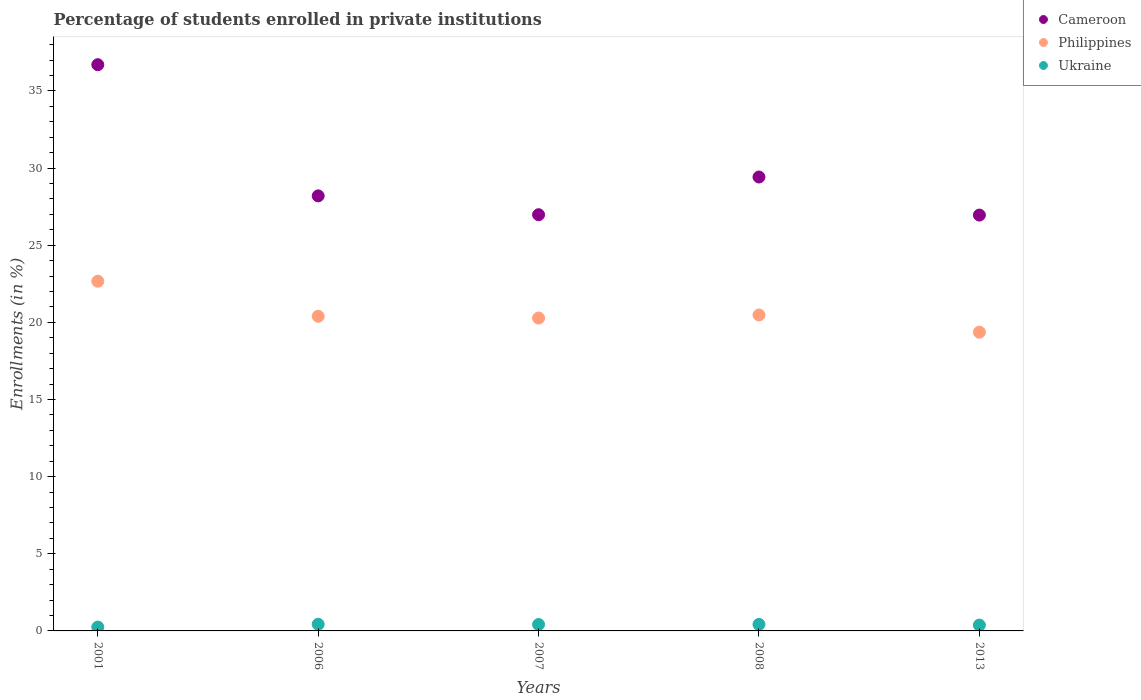Is the number of dotlines equal to the number of legend labels?
Offer a very short reply. Yes. What is the percentage of trained teachers in Ukraine in 2006?
Your response must be concise. 0.43. Across all years, what is the maximum percentage of trained teachers in Philippines?
Your response must be concise. 22.67. Across all years, what is the minimum percentage of trained teachers in Philippines?
Provide a succinct answer. 19.36. In which year was the percentage of trained teachers in Cameroon minimum?
Provide a succinct answer. 2013. What is the total percentage of trained teachers in Philippines in the graph?
Your response must be concise. 103.17. What is the difference between the percentage of trained teachers in Philippines in 2001 and that in 2013?
Offer a very short reply. 3.3. What is the difference between the percentage of trained teachers in Ukraine in 2007 and the percentage of trained teachers in Cameroon in 2008?
Provide a succinct answer. -29. What is the average percentage of trained teachers in Cameroon per year?
Keep it short and to the point. 29.65. In the year 2006, what is the difference between the percentage of trained teachers in Ukraine and percentage of trained teachers in Cameroon?
Keep it short and to the point. -27.76. What is the ratio of the percentage of trained teachers in Philippines in 2001 to that in 2006?
Offer a terse response. 1.11. Is the percentage of trained teachers in Cameroon in 2001 less than that in 2013?
Offer a terse response. No. What is the difference between the highest and the second highest percentage of trained teachers in Philippines?
Make the answer very short. 2.19. What is the difference between the highest and the lowest percentage of trained teachers in Cameroon?
Offer a very short reply. 9.75. In how many years, is the percentage of trained teachers in Philippines greater than the average percentage of trained teachers in Philippines taken over all years?
Offer a terse response. 1. Is it the case that in every year, the sum of the percentage of trained teachers in Philippines and percentage of trained teachers in Ukraine  is greater than the percentage of trained teachers in Cameroon?
Your answer should be compact. No. Does the percentage of trained teachers in Cameroon monotonically increase over the years?
Your answer should be very brief. No. How many dotlines are there?
Your answer should be very brief. 3. Does the graph contain any zero values?
Give a very brief answer. No. What is the title of the graph?
Offer a very short reply. Percentage of students enrolled in private institutions. Does "Latvia" appear as one of the legend labels in the graph?
Ensure brevity in your answer.  No. What is the label or title of the X-axis?
Provide a short and direct response. Years. What is the label or title of the Y-axis?
Give a very brief answer. Enrollments (in %). What is the Enrollments (in %) in Cameroon in 2001?
Offer a very short reply. 36.7. What is the Enrollments (in %) in Philippines in 2001?
Ensure brevity in your answer.  22.67. What is the Enrollments (in %) in Ukraine in 2001?
Ensure brevity in your answer.  0.25. What is the Enrollments (in %) in Cameroon in 2006?
Make the answer very short. 28.2. What is the Enrollments (in %) of Philippines in 2006?
Provide a short and direct response. 20.39. What is the Enrollments (in %) in Ukraine in 2006?
Offer a terse response. 0.43. What is the Enrollments (in %) of Cameroon in 2007?
Provide a succinct answer. 26.98. What is the Enrollments (in %) in Philippines in 2007?
Provide a short and direct response. 20.28. What is the Enrollments (in %) of Ukraine in 2007?
Provide a succinct answer. 0.42. What is the Enrollments (in %) of Cameroon in 2008?
Make the answer very short. 29.42. What is the Enrollments (in %) of Philippines in 2008?
Your response must be concise. 20.48. What is the Enrollments (in %) of Ukraine in 2008?
Make the answer very short. 0.42. What is the Enrollments (in %) in Cameroon in 2013?
Provide a short and direct response. 26.95. What is the Enrollments (in %) of Philippines in 2013?
Your answer should be compact. 19.36. What is the Enrollments (in %) in Ukraine in 2013?
Provide a short and direct response. 0.38. Across all years, what is the maximum Enrollments (in %) in Cameroon?
Provide a succinct answer. 36.7. Across all years, what is the maximum Enrollments (in %) of Philippines?
Your answer should be very brief. 22.67. Across all years, what is the maximum Enrollments (in %) in Ukraine?
Your response must be concise. 0.43. Across all years, what is the minimum Enrollments (in %) of Cameroon?
Your response must be concise. 26.95. Across all years, what is the minimum Enrollments (in %) of Philippines?
Make the answer very short. 19.36. Across all years, what is the minimum Enrollments (in %) in Ukraine?
Keep it short and to the point. 0.25. What is the total Enrollments (in %) in Cameroon in the graph?
Keep it short and to the point. 148.24. What is the total Enrollments (in %) in Philippines in the graph?
Your answer should be very brief. 103.17. What is the total Enrollments (in %) of Ukraine in the graph?
Provide a short and direct response. 1.9. What is the difference between the Enrollments (in %) of Cameroon in 2001 and that in 2006?
Keep it short and to the point. 8.5. What is the difference between the Enrollments (in %) of Philippines in 2001 and that in 2006?
Your answer should be compact. 2.27. What is the difference between the Enrollments (in %) of Ukraine in 2001 and that in 2006?
Your answer should be very brief. -0.18. What is the difference between the Enrollments (in %) of Cameroon in 2001 and that in 2007?
Your answer should be very brief. 9.72. What is the difference between the Enrollments (in %) in Philippines in 2001 and that in 2007?
Provide a succinct answer. 2.39. What is the difference between the Enrollments (in %) of Ukraine in 2001 and that in 2007?
Your answer should be compact. -0.17. What is the difference between the Enrollments (in %) of Cameroon in 2001 and that in 2008?
Offer a very short reply. 7.28. What is the difference between the Enrollments (in %) of Philippines in 2001 and that in 2008?
Offer a very short reply. 2.19. What is the difference between the Enrollments (in %) in Ukraine in 2001 and that in 2008?
Provide a succinct answer. -0.17. What is the difference between the Enrollments (in %) of Cameroon in 2001 and that in 2013?
Provide a succinct answer. 9.75. What is the difference between the Enrollments (in %) of Philippines in 2001 and that in 2013?
Offer a very short reply. 3.3. What is the difference between the Enrollments (in %) in Ukraine in 2001 and that in 2013?
Your answer should be compact. -0.13. What is the difference between the Enrollments (in %) in Cameroon in 2006 and that in 2007?
Offer a very short reply. 1.22. What is the difference between the Enrollments (in %) of Philippines in 2006 and that in 2007?
Your answer should be compact. 0.12. What is the difference between the Enrollments (in %) of Ukraine in 2006 and that in 2007?
Your answer should be very brief. 0.01. What is the difference between the Enrollments (in %) of Cameroon in 2006 and that in 2008?
Provide a succinct answer. -1.22. What is the difference between the Enrollments (in %) in Philippines in 2006 and that in 2008?
Keep it short and to the point. -0.08. What is the difference between the Enrollments (in %) in Ukraine in 2006 and that in 2008?
Provide a succinct answer. 0.01. What is the difference between the Enrollments (in %) of Cameroon in 2006 and that in 2013?
Give a very brief answer. 1.24. What is the difference between the Enrollments (in %) of Philippines in 2006 and that in 2013?
Your response must be concise. 1.03. What is the difference between the Enrollments (in %) in Ukraine in 2006 and that in 2013?
Your response must be concise. 0.05. What is the difference between the Enrollments (in %) in Cameroon in 2007 and that in 2008?
Provide a succinct answer. -2.44. What is the difference between the Enrollments (in %) in Philippines in 2007 and that in 2008?
Offer a very short reply. -0.2. What is the difference between the Enrollments (in %) in Ukraine in 2007 and that in 2008?
Your answer should be very brief. -0. What is the difference between the Enrollments (in %) in Cameroon in 2007 and that in 2013?
Your answer should be very brief. 0.02. What is the difference between the Enrollments (in %) of Philippines in 2007 and that in 2013?
Offer a terse response. 0.92. What is the difference between the Enrollments (in %) in Ukraine in 2007 and that in 2013?
Provide a succinct answer. 0.04. What is the difference between the Enrollments (in %) of Cameroon in 2008 and that in 2013?
Your answer should be very brief. 2.47. What is the difference between the Enrollments (in %) of Philippines in 2008 and that in 2013?
Keep it short and to the point. 1.12. What is the difference between the Enrollments (in %) in Ukraine in 2008 and that in 2013?
Provide a short and direct response. 0.04. What is the difference between the Enrollments (in %) in Cameroon in 2001 and the Enrollments (in %) in Philippines in 2006?
Provide a short and direct response. 16.31. What is the difference between the Enrollments (in %) of Cameroon in 2001 and the Enrollments (in %) of Ukraine in 2006?
Offer a terse response. 36.27. What is the difference between the Enrollments (in %) in Philippines in 2001 and the Enrollments (in %) in Ukraine in 2006?
Give a very brief answer. 22.23. What is the difference between the Enrollments (in %) in Cameroon in 2001 and the Enrollments (in %) in Philippines in 2007?
Offer a very short reply. 16.42. What is the difference between the Enrollments (in %) of Cameroon in 2001 and the Enrollments (in %) of Ukraine in 2007?
Your answer should be very brief. 36.28. What is the difference between the Enrollments (in %) in Philippines in 2001 and the Enrollments (in %) in Ukraine in 2007?
Provide a short and direct response. 22.25. What is the difference between the Enrollments (in %) of Cameroon in 2001 and the Enrollments (in %) of Philippines in 2008?
Ensure brevity in your answer.  16.22. What is the difference between the Enrollments (in %) in Cameroon in 2001 and the Enrollments (in %) in Ukraine in 2008?
Provide a short and direct response. 36.28. What is the difference between the Enrollments (in %) in Philippines in 2001 and the Enrollments (in %) in Ukraine in 2008?
Make the answer very short. 22.24. What is the difference between the Enrollments (in %) in Cameroon in 2001 and the Enrollments (in %) in Philippines in 2013?
Your response must be concise. 17.34. What is the difference between the Enrollments (in %) in Cameroon in 2001 and the Enrollments (in %) in Ukraine in 2013?
Offer a very short reply. 36.32. What is the difference between the Enrollments (in %) in Philippines in 2001 and the Enrollments (in %) in Ukraine in 2013?
Offer a terse response. 22.29. What is the difference between the Enrollments (in %) in Cameroon in 2006 and the Enrollments (in %) in Philippines in 2007?
Keep it short and to the point. 7.92. What is the difference between the Enrollments (in %) of Cameroon in 2006 and the Enrollments (in %) of Ukraine in 2007?
Make the answer very short. 27.78. What is the difference between the Enrollments (in %) of Philippines in 2006 and the Enrollments (in %) of Ukraine in 2007?
Your answer should be very brief. 19.98. What is the difference between the Enrollments (in %) in Cameroon in 2006 and the Enrollments (in %) in Philippines in 2008?
Your answer should be very brief. 7.72. What is the difference between the Enrollments (in %) in Cameroon in 2006 and the Enrollments (in %) in Ukraine in 2008?
Make the answer very short. 27.77. What is the difference between the Enrollments (in %) in Philippines in 2006 and the Enrollments (in %) in Ukraine in 2008?
Your answer should be compact. 19.97. What is the difference between the Enrollments (in %) of Cameroon in 2006 and the Enrollments (in %) of Philippines in 2013?
Keep it short and to the point. 8.84. What is the difference between the Enrollments (in %) in Cameroon in 2006 and the Enrollments (in %) in Ukraine in 2013?
Ensure brevity in your answer.  27.82. What is the difference between the Enrollments (in %) of Philippines in 2006 and the Enrollments (in %) of Ukraine in 2013?
Keep it short and to the point. 20.01. What is the difference between the Enrollments (in %) in Cameroon in 2007 and the Enrollments (in %) in Philippines in 2008?
Your answer should be very brief. 6.5. What is the difference between the Enrollments (in %) in Cameroon in 2007 and the Enrollments (in %) in Ukraine in 2008?
Give a very brief answer. 26.55. What is the difference between the Enrollments (in %) in Philippines in 2007 and the Enrollments (in %) in Ukraine in 2008?
Provide a short and direct response. 19.85. What is the difference between the Enrollments (in %) of Cameroon in 2007 and the Enrollments (in %) of Philippines in 2013?
Your response must be concise. 7.61. What is the difference between the Enrollments (in %) of Cameroon in 2007 and the Enrollments (in %) of Ukraine in 2013?
Keep it short and to the point. 26.6. What is the difference between the Enrollments (in %) in Philippines in 2007 and the Enrollments (in %) in Ukraine in 2013?
Provide a short and direct response. 19.9. What is the difference between the Enrollments (in %) of Cameroon in 2008 and the Enrollments (in %) of Philippines in 2013?
Your response must be concise. 10.06. What is the difference between the Enrollments (in %) of Cameroon in 2008 and the Enrollments (in %) of Ukraine in 2013?
Provide a succinct answer. 29.04. What is the difference between the Enrollments (in %) of Philippines in 2008 and the Enrollments (in %) of Ukraine in 2013?
Your answer should be very brief. 20.1. What is the average Enrollments (in %) in Cameroon per year?
Your response must be concise. 29.65. What is the average Enrollments (in %) in Philippines per year?
Your answer should be very brief. 20.63. What is the average Enrollments (in %) in Ukraine per year?
Your answer should be compact. 0.38. In the year 2001, what is the difference between the Enrollments (in %) in Cameroon and Enrollments (in %) in Philippines?
Provide a short and direct response. 14.03. In the year 2001, what is the difference between the Enrollments (in %) in Cameroon and Enrollments (in %) in Ukraine?
Give a very brief answer. 36.45. In the year 2001, what is the difference between the Enrollments (in %) in Philippines and Enrollments (in %) in Ukraine?
Provide a short and direct response. 22.41. In the year 2006, what is the difference between the Enrollments (in %) in Cameroon and Enrollments (in %) in Philippines?
Your answer should be very brief. 7.8. In the year 2006, what is the difference between the Enrollments (in %) in Cameroon and Enrollments (in %) in Ukraine?
Your answer should be compact. 27.76. In the year 2006, what is the difference between the Enrollments (in %) of Philippines and Enrollments (in %) of Ukraine?
Your answer should be compact. 19.96. In the year 2007, what is the difference between the Enrollments (in %) in Cameroon and Enrollments (in %) in Philippines?
Your answer should be very brief. 6.7. In the year 2007, what is the difference between the Enrollments (in %) in Cameroon and Enrollments (in %) in Ukraine?
Ensure brevity in your answer.  26.56. In the year 2007, what is the difference between the Enrollments (in %) of Philippines and Enrollments (in %) of Ukraine?
Your answer should be compact. 19.86. In the year 2008, what is the difference between the Enrollments (in %) of Cameroon and Enrollments (in %) of Philippines?
Keep it short and to the point. 8.94. In the year 2008, what is the difference between the Enrollments (in %) of Cameroon and Enrollments (in %) of Ukraine?
Offer a very short reply. 29. In the year 2008, what is the difference between the Enrollments (in %) in Philippines and Enrollments (in %) in Ukraine?
Provide a succinct answer. 20.05. In the year 2013, what is the difference between the Enrollments (in %) in Cameroon and Enrollments (in %) in Philippines?
Make the answer very short. 7.59. In the year 2013, what is the difference between the Enrollments (in %) in Cameroon and Enrollments (in %) in Ukraine?
Give a very brief answer. 26.57. In the year 2013, what is the difference between the Enrollments (in %) in Philippines and Enrollments (in %) in Ukraine?
Ensure brevity in your answer.  18.98. What is the ratio of the Enrollments (in %) in Cameroon in 2001 to that in 2006?
Keep it short and to the point. 1.3. What is the ratio of the Enrollments (in %) of Philippines in 2001 to that in 2006?
Your answer should be compact. 1.11. What is the ratio of the Enrollments (in %) of Ukraine in 2001 to that in 2006?
Provide a succinct answer. 0.58. What is the ratio of the Enrollments (in %) of Cameroon in 2001 to that in 2007?
Provide a succinct answer. 1.36. What is the ratio of the Enrollments (in %) in Philippines in 2001 to that in 2007?
Provide a succinct answer. 1.12. What is the ratio of the Enrollments (in %) in Ukraine in 2001 to that in 2007?
Offer a very short reply. 0.6. What is the ratio of the Enrollments (in %) of Cameroon in 2001 to that in 2008?
Offer a terse response. 1.25. What is the ratio of the Enrollments (in %) in Philippines in 2001 to that in 2008?
Provide a succinct answer. 1.11. What is the ratio of the Enrollments (in %) of Ukraine in 2001 to that in 2008?
Offer a very short reply. 0.59. What is the ratio of the Enrollments (in %) of Cameroon in 2001 to that in 2013?
Give a very brief answer. 1.36. What is the ratio of the Enrollments (in %) in Philippines in 2001 to that in 2013?
Your answer should be very brief. 1.17. What is the ratio of the Enrollments (in %) of Ukraine in 2001 to that in 2013?
Offer a very short reply. 0.66. What is the ratio of the Enrollments (in %) in Cameroon in 2006 to that in 2007?
Offer a very short reply. 1.05. What is the ratio of the Enrollments (in %) of Ukraine in 2006 to that in 2007?
Your answer should be very brief. 1.03. What is the ratio of the Enrollments (in %) of Cameroon in 2006 to that in 2008?
Your answer should be compact. 0.96. What is the ratio of the Enrollments (in %) in Ukraine in 2006 to that in 2008?
Provide a succinct answer. 1.02. What is the ratio of the Enrollments (in %) of Cameroon in 2006 to that in 2013?
Make the answer very short. 1.05. What is the ratio of the Enrollments (in %) in Philippines in 2006 to that in 2013?
Offer a very short reply. 1.05. What is the ratio of the Enrollments (in %) in Ukraine in 2006 to that in 2013?
Provide a succinct answer. 1.14. What is the ratio of the Enrollments (in %) in Cameroon in 2007 to that in 2008?
Keep it short and to the point. 0.92. What is the ratio of the Enrollments (in %) of Philippines in 2007 to that in 2008?
Provide a short and direct response. 0.99. What is the ratio of the Enrollments (in %) of Ukraine in 2007 to that in 2008?
Give a very brief answer. 0.99. What is the ratio of the Enrollments (in %) in Philippines in 2007 to that in 2013?
Your response must be concise. 1.05. What is the ratio of the Enrollments (in %) of Ukraine in 2007 to that in 2013?
Provide a succinct answer. 1.1. What is the ratio of the Enrollments (in %) in Cameroon in 2008 to that in 2013?
Offer a very short reply. 1.09. What is the ratio of the Enrollments (in %) of Philippines in 2008 to that in 2013?
Make the answer very short. 1.06. What is the ratio of the Enrollments (in %) of Ukraine in 2008 to that in 2013?
Offer a terse response. 1.12. What is the difference between the highest and the second highest Enrollments (in %) in Cameroon?
Provide a short and direct response. 7.28. What is the difference between the highest and the second highest Enrollments (in %) of Philippines?
Keep it short and to the point. 2.19. What is the difference between the highest and the second highest Enrollments (in %) in Ukraine?
Ensure brevity in your answer.  0.01. What is the difference between the highest and the lowest Enrollments (in %) in Cameroon?
Give a very brief answer. 9.75. What is the difference between the highest and the lowest Enrollments (in %) of Philippines?
Provide a short and direct response. 3.3. What is the difference between the highest and the lowest Enrollments (in %) in Ukraine?
Your answer should be compact. 0.18. 